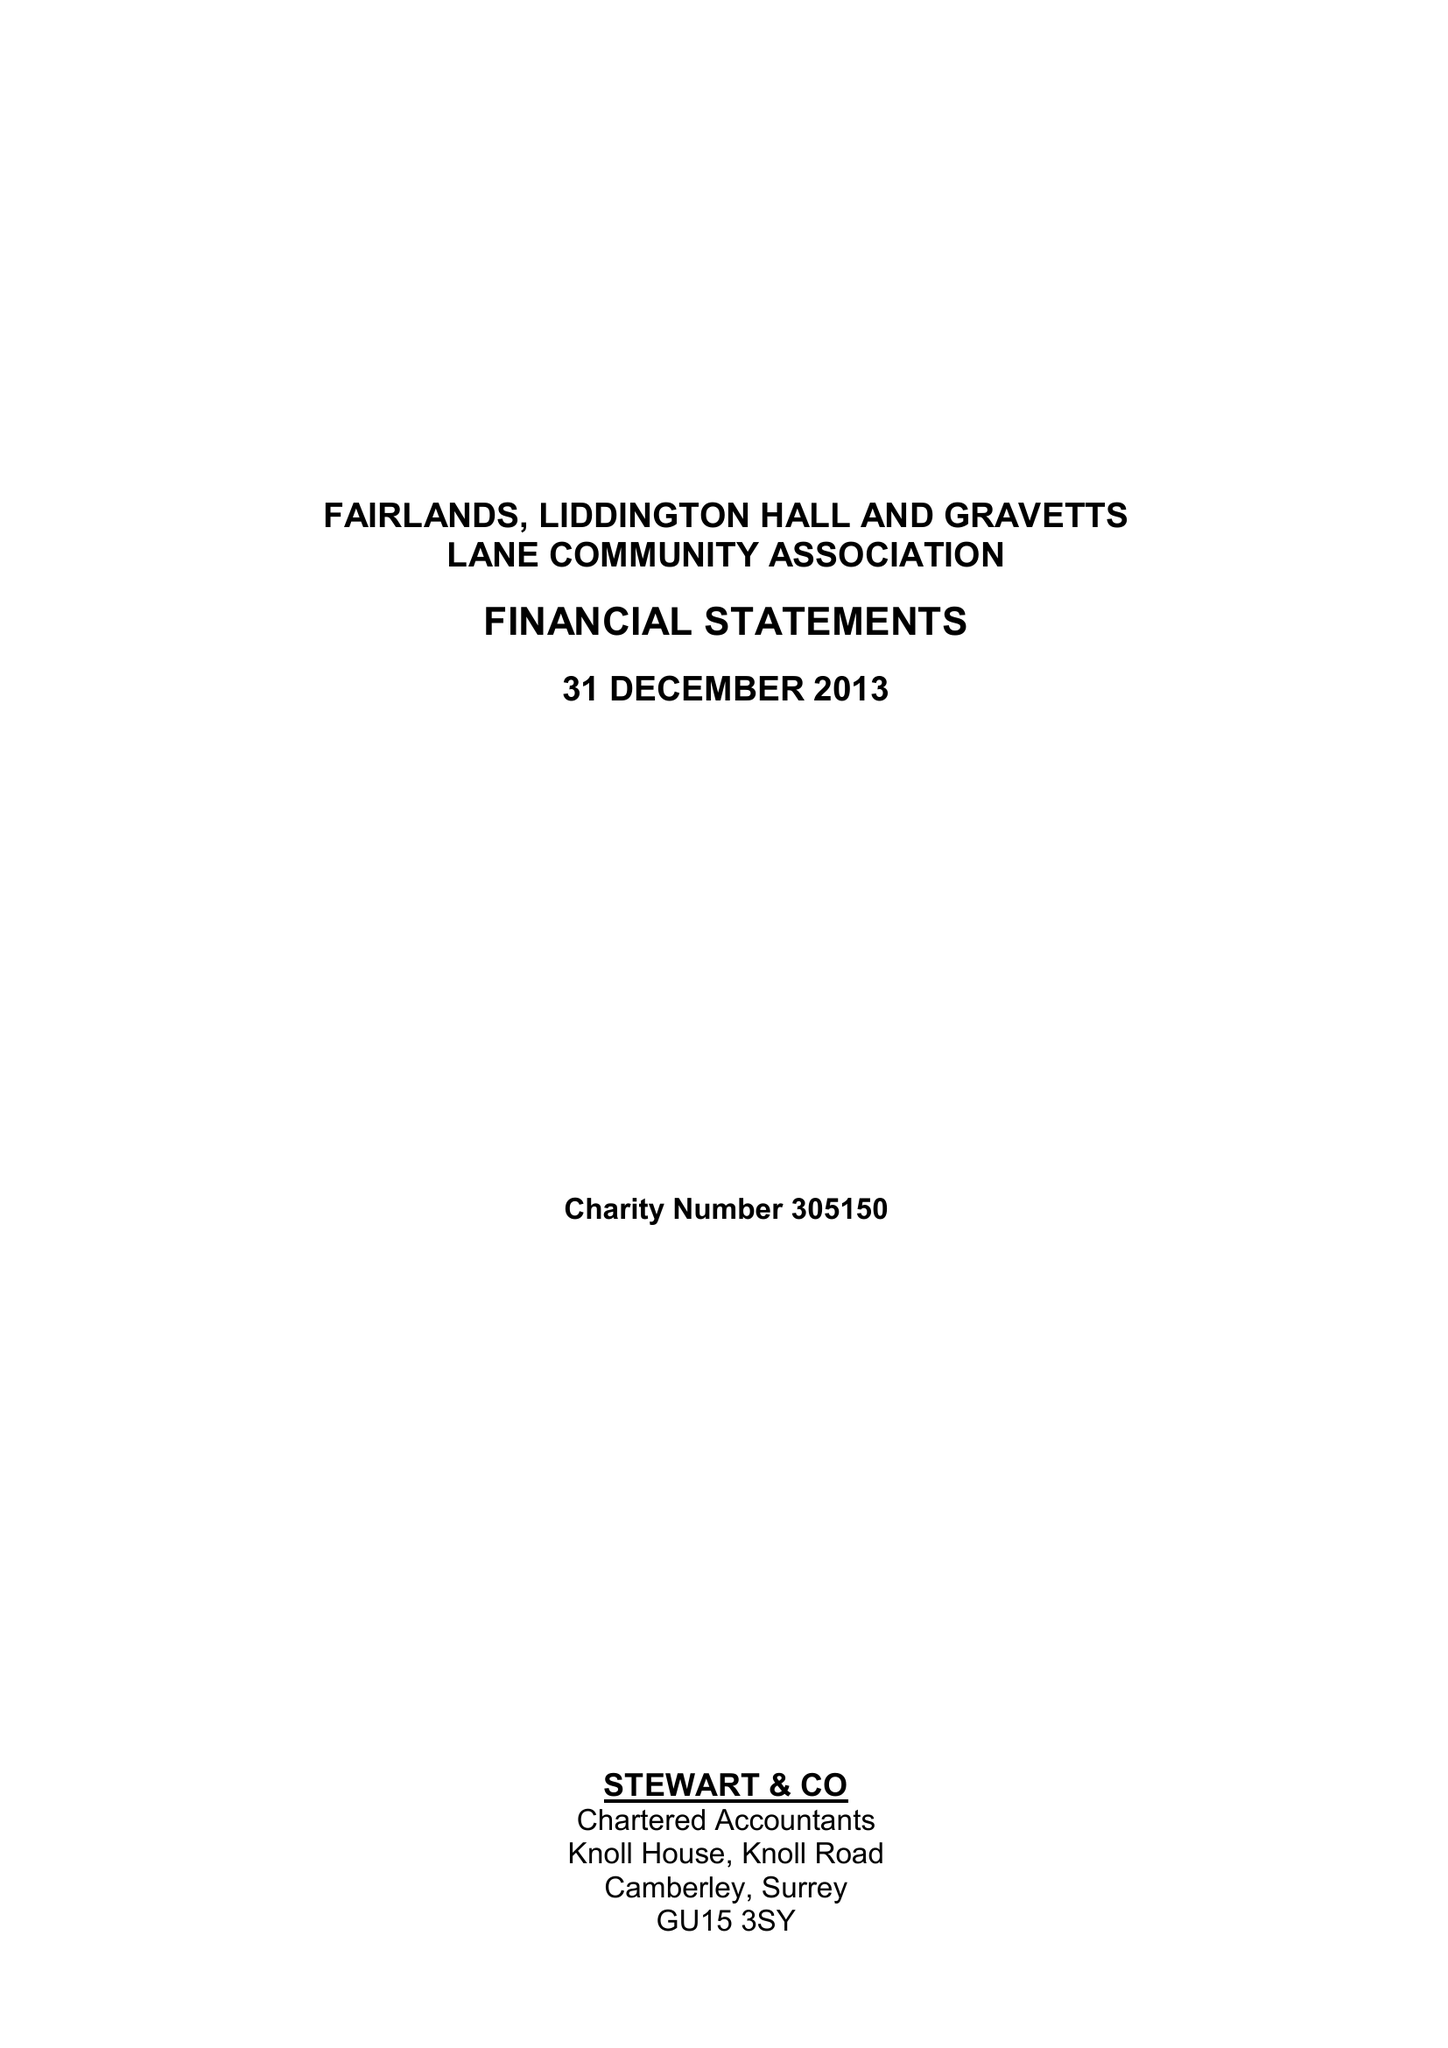What is the value for the address__postcode?
Answer the question using a single word or phrase. GU3 3NA 